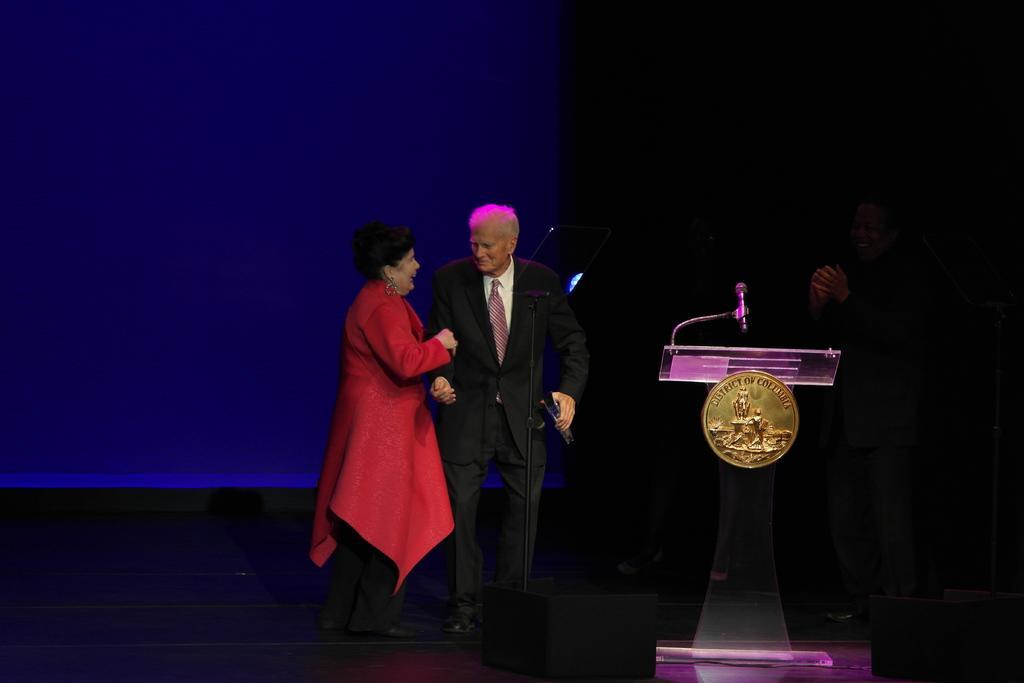Describe this image in one or two sentences. In this image I can see a woman wearing red and black colored dress and a man wearing black and white colored dress are standing. I can see a podium, and microphone on the podium, a person standing, the screen and the dark background. 